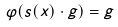Convert formula to latex. <formula><loc_0><loc_0><loc_500><loc_500>\varphi ( s ( x ) \cdot g ) = g</formula> 